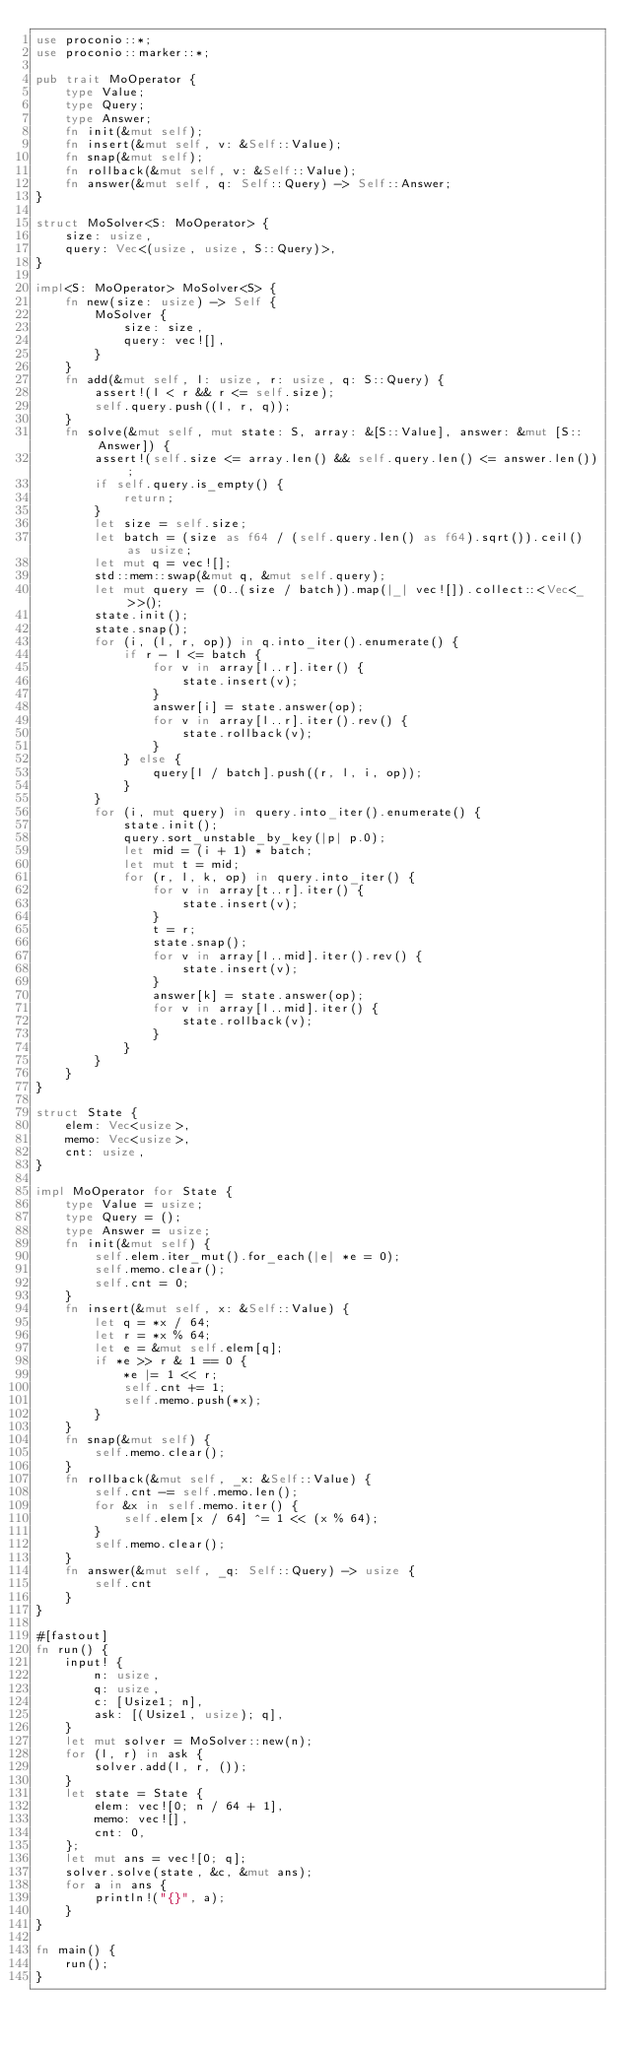<code> <loc_0><loc_0><loc_500><loc_500><_Rust_>use proconio::*;
use proconio::marker::*;

pub trait MoOperator {
    type Value;
    type Query;
    type Answer;
    fn init(&mut self);
    fn insert(&mut self, v: &Self::Value);
    fn snap(&mut self);
    fn rollback(&mut self, v: &Self::Value);
    fn answer(&mut self, q: Self::Query) -> Self::Answer;
}

struct MoSolver<S: MoOperator> {
    size: usize,
    query: Vec<(usize, usize, S::Query)>,
}

impl<S: MoOperator> MoSolver<S> {
    fn new(size: usize) -> Self {
        MoSolver {
            size: size,
            query: vec![],
        }
    }
    fn add(&mut self, l: usize, r: usize, q: S::Query) {
        assert!(l < r && r <= self.size);
        self.query.push((l, r, q));
    }
    fn solve(&mut self, mut state: S, array: &[S::Value], answer: &mut [S::Answer]) {
        assert!(self.size <= array.len() && self.query.len() <= answer.len());
        if self.query.is_empty() {
            return;
        }
        let size = self.size;
        let batch = (size as f64 / (self.query.len() as f64).sqrt()).ceil() as usize;
        let mut q = vec![];
        std::mem::swap(&mut q, &mut self.query);
        let mut query = (0..(size / batch)).map(|_| vec![]).collect::<Vec<_>>();
        state.init();
        state.snap();
        for (i, (l, r, op)) in q.into_iter().enumerate() {
            if r - l <= batch {
                for v in array[l..r].iter() {
                    state.insert(v);
                }
                answer[i] = state.answer(op);
                for v in array[l..r].iter().rev() {
                    state.rollback(v);
                }
            } else {
                query[l / batch].push((r, l, i, op));
            }
        }
        for (i, mut query) in query.into_iter().enumerate() {
            state.init();
            query.sort_unstable_by_key(|p| p.0);
            let mid = (i + 1) * batch;
            let mut t = mid;
            for (r, l, k, op) in query.into_iter() {
                for v in array[t..r].iter() {
                    state.insert(v);
                }
                t = r;
                state.snap();
                for v in array[l..mid].iter().rev() {
                    state.insert(v);
                }
                answer[k] = state.answer(op);
                for v in array[l..mid].iter() {
                    state.rollback(v);
                }
            }
        }
    }
}

struct State {
    elem: Vec<usize>,
    memo: Vec<usize>,
    cnt: usize,
}

impl MoOperator for State {
    type Value = usize;
    type Query = ();
    type Answer = usize;
    fn init(&mut self) {
        self.elem.iter_mut().for_each(|e| *e = 0);
        self.memo.clear();
        self.cnt = 0;
    }
    fn insert(&mut self, x: &Self::Value) {
        let q = *x / 64;
        let r = *x % 64;
        let e = &mut self.elem[q];
        if *e >> r & 1 == 0 {
            *e |= 1 << r;
            self.cnt += 1;
            self.memo.push(*x);
        }
    }
    fn snap(&mut self) {
        self.memo.clear();
    }
    fn rollback(&mut self, _x: &Self::Value) {
        self.cnt -= self.memo.len();
        for &x in self.memo.iter() {
            self.elem[x / 64] ^= 1 << (x % 64);
        }
        self.memo.clear();
    }
    fn answer(&mut self, _q: Self::Query) -> usize {
        self.cnt
    }
}

#[fastout]
fn run() {
    input! {
        n: usize,
        q: usize,
        c: [Usize1; n],
        ask: [(Usize1, usize); q],
    }
    let mut solver = MoSolver::new(n);
    for (l, r) in ask {
        solver.add(l, r, ());
    }
    let state = State {
        elem: vec![0; n / 64 + 1],
        memo: vec![],
        cnt: 0,
    };
    let mut ans = vec![0; q];
    solver.solve(state, &c, &mut ans);
    for a in ans {
        println!("{}", a);
    }
}

fn main() {
    run();
}
</code> 